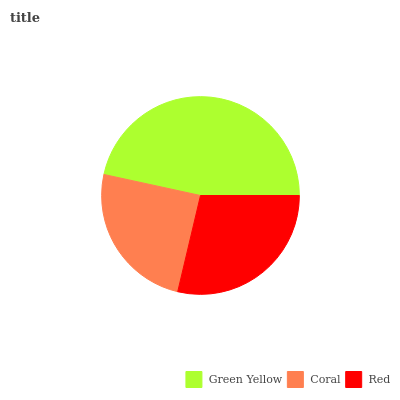Is Coral the minimum?
Answer yes or no. Yes. Is Green Yellow the maximum?
Answer yes or no. Yes. Is Red the minimum?
Answer yes or no. No. Is Red the maximum?
Answer yes or no. No. Is Red greater than Coral?
Answer yes or no. Yes. Is Coral less than Red?
Answer yes or no. Yes. Is Coral greater than Red?
Answer yes or no. No. Is Red less than Coral?
Answer yes or no. No. Is Red the high median?
Answer yes or no. Yes. Is Red the low median?
Answer yes or no. Yes. Is Green Yellow the high median?
Answer yes or no. No. Is Green Yellow the low median?
Answer yes or no. No. 